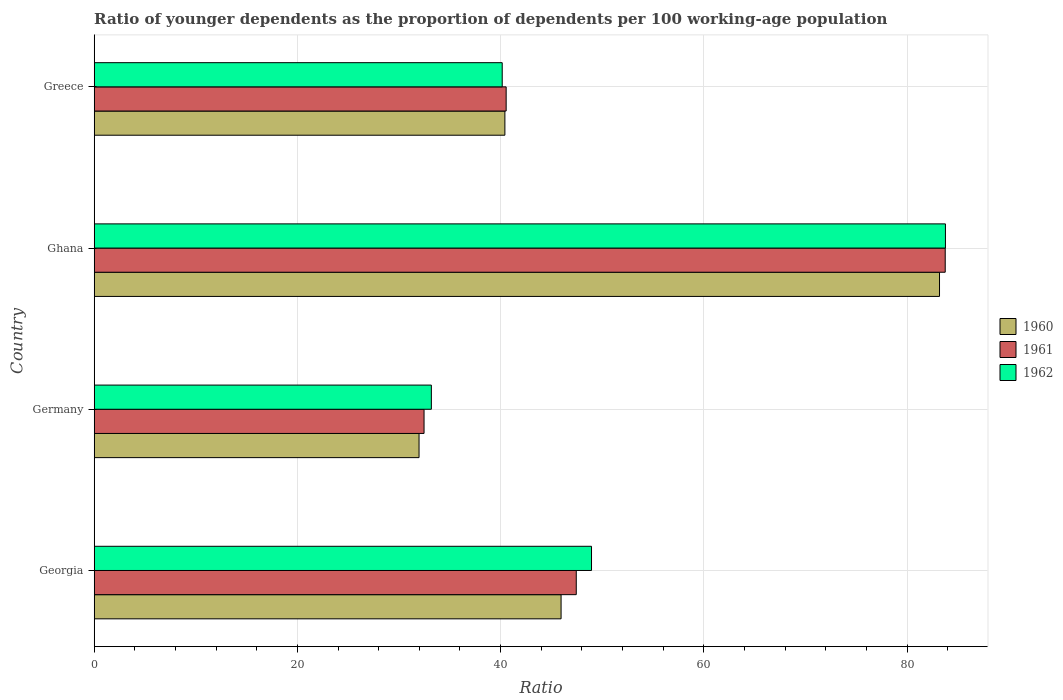Are the number of bars per tick equal to the number of legend labels?
Offer a terse response. Yes. What is the label of the 4th group of bars from the top?
Your response must be concise. Georgia. In how many cases, is the number of bars for a given country not equal to the number of legend labels?
Your answer should be compact. 0. What is the age dependency ratio(young) in 1960 in Georgia?
Provide a short and direct response. 45.95. Across all countries, what is the maximum age dependency ratio(young) in 1962?
Your response must be concise. 83.78. Across all countries, what is the minimum age dependency ratio(young) in 1962?
Keep it short and to the point. 33.19. What is the total age dependency ratio(young) in 1962 in the graph?
Your answer should be compact. 206.07. What is the difference between the age dependency ratio(young) in 1962 in Germany and that in Ghana?
Offer a very short reply. -50.6. What is the difference between the age dependency ratio(young) in 1962 in Greece and the age dependency ratio(young) in 1961 in Germany?
Your answer should be compact. 7.69. What is the average age dependency ratio(young) in 1960 per country?
Keep it short and to the point. 50.39. What is the difference between the age dependency ratio(young) in 1960 and age dependency ratio(young) in 1961 in Georgia?
Offer a very short reply. -1.49. In how many countries, is the age dependency ratio(young) in 1961 greater than 4 ?
Keep it short and to the point. 4. What is the ratio of the age dependency ratio(young) in 1961 in Georgia to that in Germany?
Your answer should be compact. 1.46. Is the difference between the age dependency ratio(young) in 1960 in Germany and Ghana greater than the difference between the age dependency ratio(young) in 1961 in Germany and Ghana?
Your answer should be very brief. Yes. What is the difference between the highest and the second highest age dependency ratio(young) in 1962?
Keep it short and to the point. 34.83. What is the difference between the highest and the lowest age dependency ratio(young) in 1960?
Offer a terse response. 51.23. In how many countries, is the age dependency ratio(young) in 1961 greater than the average age dependency ratio(young) in 1961 taken over all countries?
Provide a succinct answer. 1. What does the 2nd bar from the top in Germany represents?
Offer a very short reply. 1961. What does the 2nd bar from the bottom in Ghana represents?
Your response must be concise. 1961. Are all the bars in the graph horizontal?
Ensure brevity in your answer.  Yes. Does the graph contain any zero values?
Your response must be concise. No. Does the graph contain grids?
Your answer should be compact. Yes. How are the legend labels stacked?
Make the answer very short. Vertical. What is the title of the graph?
Offer a very short reply. Ratio of younger dependents as the proportion of dependents per 100 working-age population. Does "1996" appear as one of the legend labels in the graph?
Your answer should be compact. No. What is the label or title of the X-axis?
Provide a succinct answer. Ratio. What is the label or title of the Y-axis?
Offer a terse response. Country. What is the Ratio in 1960 in Georgia?
Offer a very short reply. 45.95. What is the Ratio of 1961 in Georgia?
Offer a terse response. 47.45. What is the Ratio in 1962 in Georgia?
Offer a terse response. 48.95. What is the Ratio of 1960 in Germany?
Keep it short and to the point. 31.97. What is the Ratio of 1961 in Germany?
Make the answer very short. 32.47. What is the Ratio of 1962 in Germany?
Give a very brief answer. 33.19. What is the Ratio of 1960 in Ghana?
Your answer should be very brief. 83.2. What is the Ratio of 1961 in Ghana?
Give a very brief answer. 83.76. What is the Ratio of 1962 in Ghana?
Give a very brief answer. 83.78. What is the Ratio of 1960 in Greece?
Your answer should be very brief. 40.42. What is the Ratio in 1961 in Greece?
Make the answer very short. 40.55. What is the Ratio in 1962 in Greece?
Give a very brief answer. 40.16. Across all countries, what is the maximum Ratio of 1960?
Ensure brevity in your answer.  83.2. Across all countries, what is the maximum Ratio in 1961?
Offer a very short reply. 83.76. Across all countries, what is the maximum Ratio of 1962?
Offer a terse response. 83.78. Across all countries, what is the minimum Ratio in 1960?
Your response must be concise. 31.97. Across all countries, what is the minimum Ratio of 1961?
Keep it short and to the point. 32.47. Across all countries, what is the minimum Ratio in 1962?
Ensure brevity in your answer.  33.19. What is the total Ratio of 1960 in the graph?
Your response must be concise. 201.55. What is the total Ratio in 1961 in the graph?
Offer a terse response. 204.22. What is the total Ratio of 1962 in the graph?
Provide a succinct answer. 206.07. What is the difference between the Ratio in 1960 in Georgia and that in Germany?
Your response must be concise. 13.98. What is the difference between the Ratio in 1961 in Georgia and that in Germany?
Offer a very short reply. 14.98. What is the difference between the Ratio in 1962 in Georgia and that in Germany?
Provide a succinct answer. 15.76. What is the difference between the Ratio in 1960 in Georgia and that in Ghana?
Your answer should be very brief. -37.25. What is the difference between the Ratio in 1961 in Georgia and that in Ghana?
Your answer should be compact. -36.32. What is the difference between the Ratio of 1962 in Georgia and that in Ghana?
Give a very brief answer. -34.83. What is the difference between the Ratio in 1960 in Georgia and that in Greece?
Provide a short and direct response. 5.53. What is the difference between the Ratio in 1961 in Georgia and that in Greece?
Provide a short and direct response. 6.9. What is the difference between the Ratio of 1962 in Georgia and that in Greece?
Provide a short and direct response. 8.79. What is the difference between the Ratio in 1960 in Germany and that in Ghana?
Offer a very short reply. -51.23. What is the difference between the Ratio of 1961 in Germany and that in Ghana?
Your answer should be compact. -51.3. What is the difference between the Ratio in 1962 in Germany and that in Ghana?
Your response must be concise. -50.6. What is the difference between the Ratio in 1960 in Germany and that in Greece?
Make the answer very short. -8.45. What is the difference between the Ratio of 1961 in Germany and that in Greece?
Make the answer very short. -8.08. What is the difference between the Ratio of 1962 in Germany and that in Greece?
Your answer should be very brief. -6.97. What is the difference between the Ratio of 1960 in Ghana and that in Greece?
Ensure brevity in your answer.  42.78. What is the difference between the Ratio in 1961 in Ghana and that in Greece?
Keep it short and to the point. 43.21. What is the difference between the Ratio in 1962 in Ghana and that in Greece?
Offer a terse response. 43.62. What is the difference between the Ratio in 1960 in Georgia and the Ratio in 1961 in Germany?
Your answer should be compact. 13.49. What is the difference between the Ratio of 1960 in Georgia and the Ratio of 1962 in Germany?
Your answer should be very brief. 12.77. What is the difference between the Ratio of 1961 in Georgia and the Ratio of 1962 in Germany?
Provide a short and direct response. 14.26. What is the difference between the Ratio of 1960 in Georgia and the Ratio of 1961 in Ghana?
Keep it short and to the point. -37.81. What is the difference between the Ratio of 1960 in Georgia and the Ratio of 1962 in Ghana?
Your response must be concise. -37.83. What is the difference between the Ratio of 1961 in Georgia and the Ratio of 1962 in Ghana?
Keep it short and to the point. -36.34. What is the difference between the Ratio in 1960 in Georgia and the Ratio in 1961 in Greece?
Keep it short and to the point. 5.41. What is the difference between the Ratio of 1960 in Georgia and the Ratio of 1962 in Greece?
Make the answer very short. 5.79. What is the difference between the Ratio in 1961 in Georgia and the Ratio in 1962 in Greece?
Provide a short and direct response. 7.29. What is the difference between the Ratio of 1960 in Germany and the Ratio of 1961 in Ghana?
Ensure brevity in your answer.  -51.79. What is the difference between the Ratio in 1960 in Germany and the Ratio in 1962 in Ghana?
Your answer should be very brief. -51.81. What is the difference between the Ratio of 1961 in Germany and the Ratio of 1962 in Ghana?
Your response must be concise. -51.32. What is the difference between the Ratio of 1960 in Germany and the Ratio of 1961 in Greece?
Your answer should be compact. -8.57. What is the difference between the Ratio of 1960 in Germany and the Ratio of 1962 in Greece?
Ensure brevity in your answer.  -8.19. What is the difference between the Ratio of 1961 in Germany and the Ratio of 1962 in Greece?
Provide a succinct answer. -7.69. What is the difference between the Ratio of 1960 in Ghana and the Ratio of 1961 in Greece?
Your response must be concise. 42.65. What is the difference between the Ratio of 1960 in Ghana and the Ratio of 1962 in Greece?
Your response must be concise. 43.04. What is the difference between the Ratio of 1961 in Ghana and the Ratio of 1962 in Greece?
Ensure brevity in your answer.  43.6. What is the average Ratio in 1960 per country?
Provide a succinct answer. 50.39. What is the average Ratio of 1961 per country?
Offer a very short reply. 51.06. What is the average Ratio in 1962 per country?
Your answer should be compact. 51.52. What is the difference between the Ratio in 1960 and Ratio in 1961 in Georgia?
Give a very brief answer. -1.49. What is the difference between the Ratio of 1960 and Ratio of 1962 in Georgia?
Your answer should be very brief. -3. What is the difference between the Ratio of 1961 and Ratio of 1962 in Georgia?
Make the answer very short. -1.5. What is the difference between the Ratio of 1960 and Ratio of 1961 in Germany?
Provide a short and direct response. -0.49. What is the difference between the Ratio of 1960 and Ratio of 1962 in Germany?
Provide a short and direct response. -1.21. What is the difference between the Ratio in 1961 and Ratio in 1962 in Germany?
Offer a very short reply. -0.72. What is the difference between the Ratio of 1960 and Ratio of 1961 in Ghana?
Offer a very short reply. -0.56. What is the difference between the Ratio in 1960 and Ratio in 1962 in Ghana?
Offer a very short reply. -0.58. What is the difference between the Ratio in 1961 and Ratio in 1962 in Ghana?
Give a very brief answer. -0.02. What is the difference between the Ratio in 1960 and Ratio in 1961 in Greece?
Offer a very short reply. -0.12. What is the difference between the Ratio in 1960 and Ratio in 1962 in Greece?
Make the answer very short. 0.26. What is the difference between the Ratio of 1961 and Ratio of 1962 in Greece?
Your response must be concise. 0.39. What is the ratio of the Ratio in 1960 in Georgia to that in Germany?
Give a very brief answer. 1.44. What is the ratio of the Ratio of 1961 in Georgia to that in Germany?
Ensure brevity in your answer.  1.46. What is the ratio of the Ratio of 1962 in Georgia to that in Germany?
Your response must be concise. 1.48. What is the ratio of the Ratio of 1960 in Georgia to that in Ghana?
Make the answer very short. 0.55. What is the ratio of the Ratio of 1961 in Georgia to that in Ghana?
Your answer should be very brief. 0.57. What is the ratio of the Ratio of 1962 in Georgia to that in Ghana?
Provide a short and direct response. 0.58. What is the ratio of the Ratio of 1960 in Georgia to that in Greece?
Your answer should be very brief. 1.14. What is the ratio of the Ratio of 1961 in Georgia to that in Greece?
Your answer should be very brief. 1.17. What is the ratio of the Ratio in 1962 in Georgia to that in Greece?
Ensure brevity in your answer.  1.22. What is the ratio of the Ratio in 1960 in Germany to that in Ghana?
Ensure brevity in your answer.  0.38. What is the ratio of the Ratio of 1961 in Germany to that in Ghana?
Provide a succinct answer. 0.39. What is the ratio of the Ratio of 1962 in Germany to that in Ghana?
Give a very brief answer. 0.4. What is the ratio of the Ratio of 1960 in Germany to that in Greece?
Keep it short and to the point. 0.79. What is the ratio of the Ratio of 1961 in Germany to that in Greece?
Make the answer very short. 0.8. What is the ratio of the Ratio of 1962 in Germany to that in Greece?
Provide a succinct answer. 0.83. What is the ratio of the Ratio in 1960 in Ghana to that in Greece?
Your response must be concise. 2.06. What is the ratio of the Ratio of 1961 in Ghana to that in Greece?
Your answer should be compact. 2.07. What is the ratio of the Ratio in 1962 in Ghana to that in Greece?
Provide a short and direct response. 2.09. What is the difference between the highest and the second highest Ratio of 1960?
Ensure brevity in your answer.  37.25. What is the difference between the highest and the second highest Ratio of 1961?
Provide a succinct answer. 36.32. What is the difference between the highest and the second highest Ratio of 1962?
Make the answer very short. 34.83. What is the difference between the highest and the lowest Ratio in 1960?
Your answer should be compact. 51.23. What is the difference between the highest and the lowest Ratio in 1961?
Offer a terse response. 51.3. What is the difference between the highest and the lowest Ratio of 1962?
Your response must be concise. 50.6. 